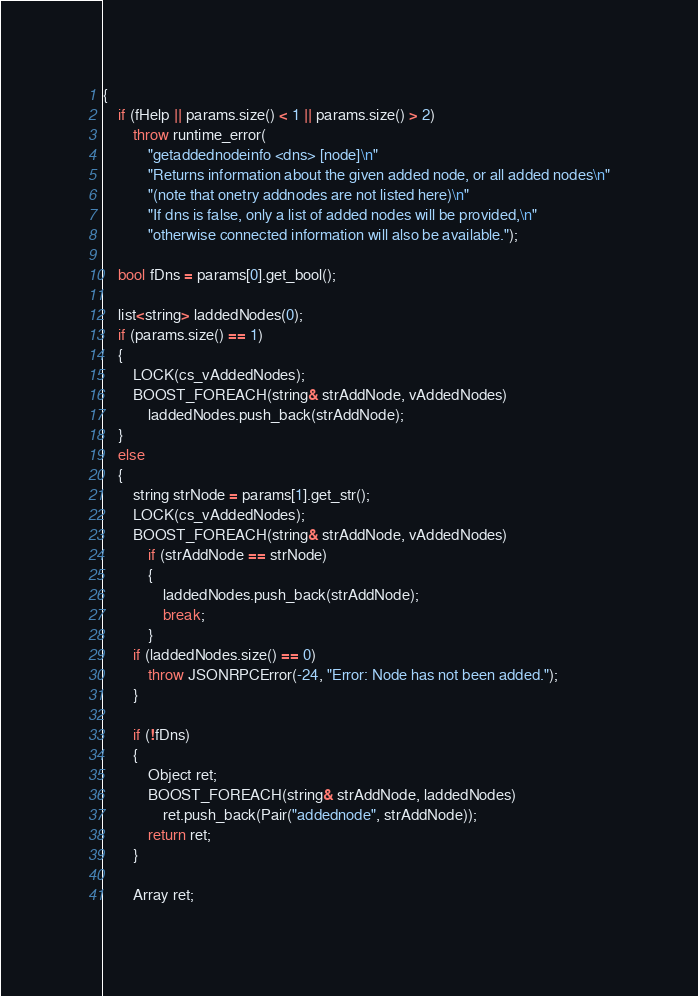<code> <loc_0><loc_0><loc_500><loc_500><_C++_>{
    if (fHelp || params.size() < 1 || params.size() > 2)
        throw runtime_error(
            "getaddednodeinfo <dns> [node]\n"
            "Returns information about the given added node, or all added nodes\n"
            "(note that onetry addnodes are not listed here)\n"
            "If dns is false, only a list of added nodes will be provided,\n"
            "otherwise connected information will also be available.");

    bool fDns = params[0].get_bool();

    list<string> laddedNodes(0);
    if (params.size() == 1)
    {
        LOCK(cs_vAddedNodes);
        BOOST_FOREACH(string& strAddNode, vAddedNodes)
            laddedNodes.push_back(strAddNode);
    }
    else
    {
        string strNode = params[1].get_str();
        LOCK(cs_vAddedNodes);
        BOOST_FOREACH(string& strAddNode, vAddedNodes)
            if (strAddNode == strNode)
            {
                laddedNodes.push_back(strAddNode);
                break;
            }
        if (laddedNodes.size() == 0)
            throw JSONRPCError(-24, "Error: Node has not been added.");
        }

        if (!fDns)
        {
            Object ret;
            BOOST_FOREACH(string& strAddNode, laddedNodes)
                ret.push_back(Pair("addednode", strAddNode));
            return ret;
        }

        Array ret;
</code> 